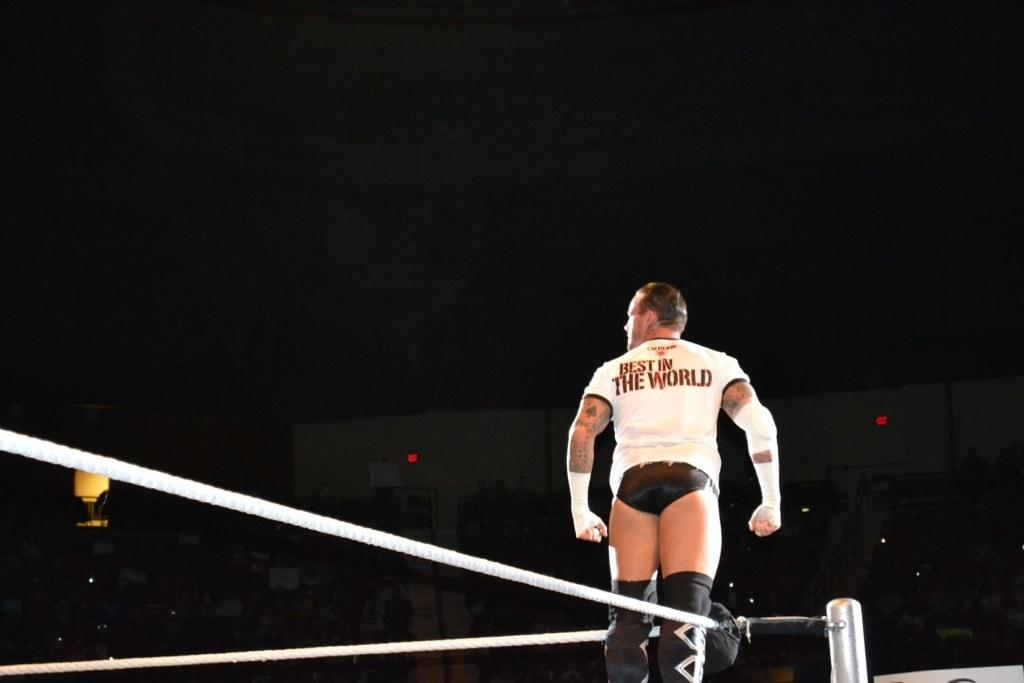<image>
Render a clear and concise summary of the photo. A man is in a white shirt with the word world on the back. 